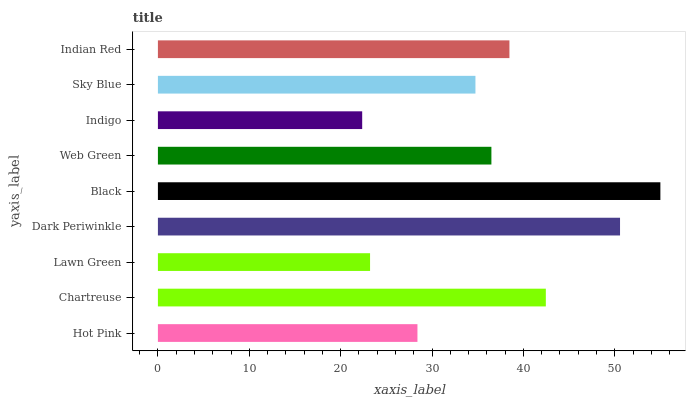Is Indigo the minimum?
Answer yes or no. Yes. Is Black the maximum?
Answer yes or no. Yes. Is Chartreuse the minimum?
Answer yes or no. No. Is Chartreuse the maximum?
Answer yes or no. No. Is Chartreuse greater than Hot Pink?
Answer yes or no. Yes. Is Hot Pink less than Chartreuse?
Answer yes or no. Yes. Is Hot Pink greater than Chartreuse?
Answer yes or no. No. Is Chartreuse less than Hot Pink?
Answer yes or no. No. Is Web Green the high median?
Answer yes or no. Yes. Is Web Green the low median?
Answer yes or no. Yes. Is Sky Blue the high median?
Answer yes or no. No. Is Hot Pink the low median?
Answer yes or no. No. 